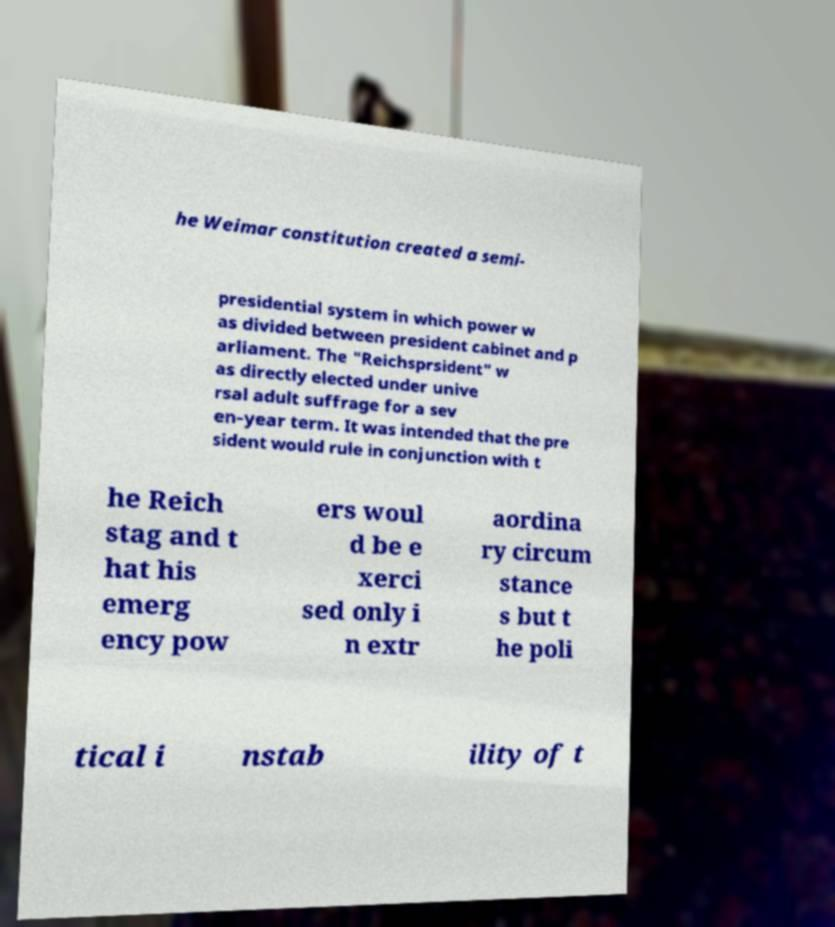Please read and relay the text visible in this image. What does it say? he Weimar constitution created a semi- presidential system in which power w as divided between president cabinet and p arliament. The "Reichsprsident" w as directly elected under unive rsal adult suffrage for a sev en-year term. It was intended that the pre sident would rule in conjunction with t he Reich stag and t hat his emerg ency pow ers woul d be e xerci sed only i n extr aordina ry circum stance s but t he poli tical i nstab ility of t 